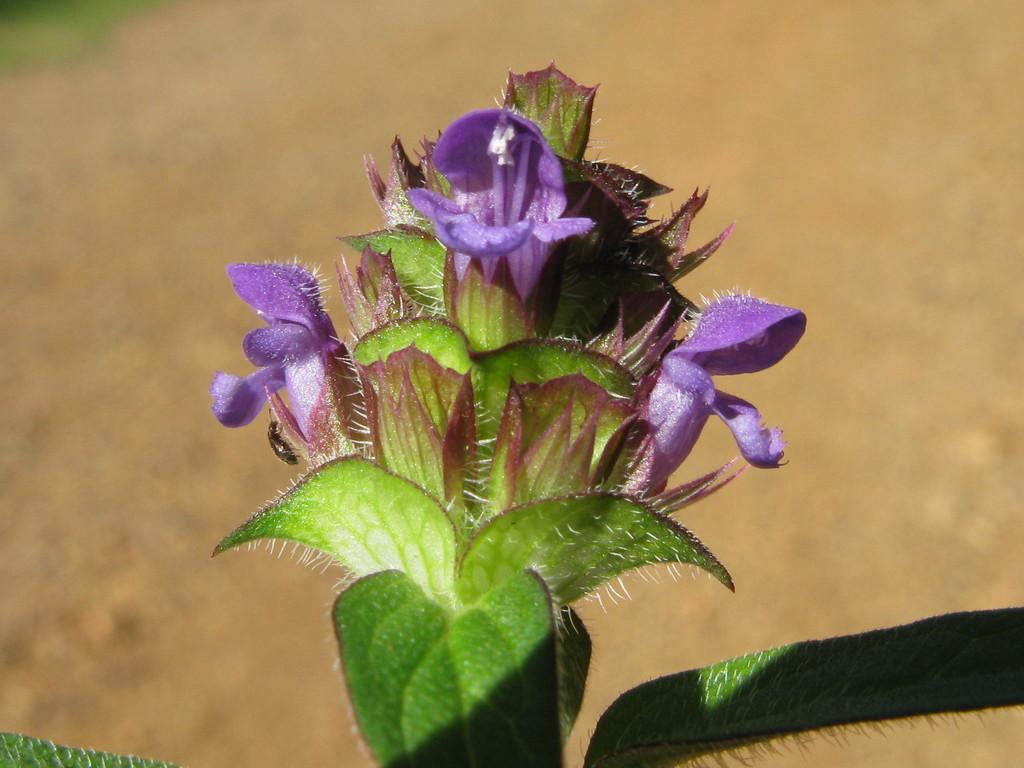What is the main subject in the center of the image? There is a plant in the center of the image. What type of noise can be heard coming from the cars in the image? There are no cars present in the image, so it's not possible to determine what, if any, noise might be heard. 